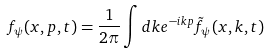Convert formula to latex. <formula><loc_0><loc_0><loc_500><loc_500>f _ { \psi } ( x , p , t ) = \frac { 1 } { 2 \pi } \int d k e ^ { - i k p } \tilde { f } _ { \psi } ( x , k , t )</formula> 